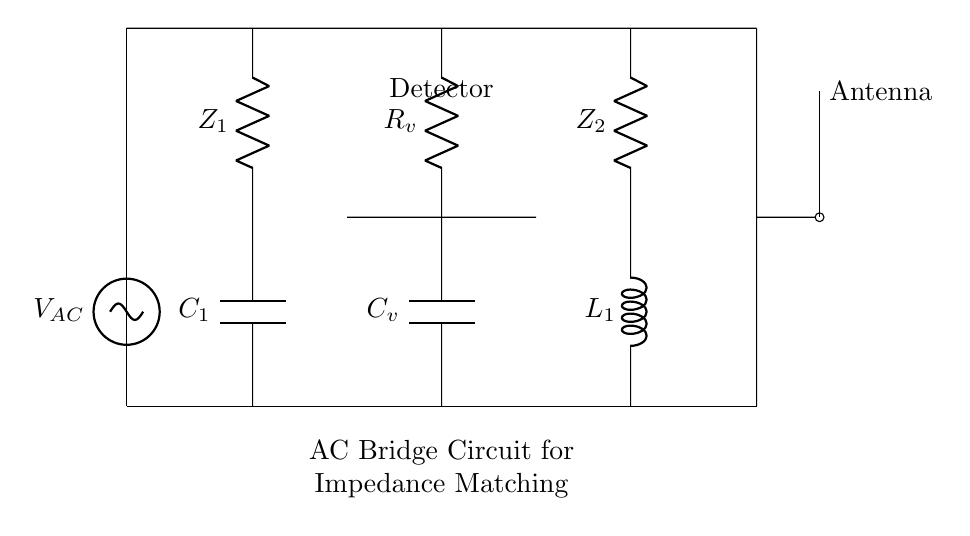What is the voltage source in the circuit? The voltage source is labeled as V_AC, which provides the alternating current needed for the circuit.
Answer: V_AC What types of impedance components are present in the circuit? The components include resistors, a capacitor, and an inductor, specifically labeled as Z1 (resistor), C1 (capacitor), Z2 (resistor), and L1 (inductor).
Answer: Resistor, capacitor, inductor What is the purpose of the detector in the circuit? The detector is positioned to sense the balance condition of the bridge circuit, indicating when the impedances are matched for optimal performance.
Answer: To sense balance Which component represents the antenna in the circuit? The antenna is indicated at the right end of the circuit diagram, connected at the output where the signal is delivered, helping to transmit or receive radio waves.
Answer: Antenna How many branches are present in the bridge circuit? The bridge circuit has four branches, which include the two pairs of impedance (Z1 with C1 and Z2 with L1) and one branch for the voltage source and one for the detector.
Answer: Four What is the role of the capacitive component labeled C_v? C_v is a coupling capacitor, which helps to block any DC components in the signal while allowing AC signals to pass through, enabling better signal processing.
Answer: Coupling capacitor How are the impedance matching and the performance of radio communication related in this circuit? The impedance matching through the bridge ensures maximum power transfer from the source to the antenna, which is critical for effective radio communication performance.
Answer: Maximum power transfer 